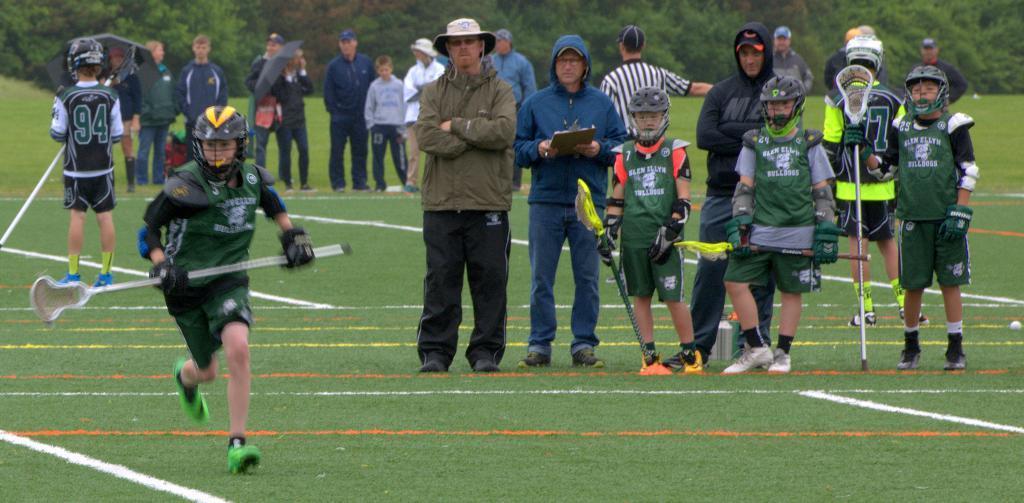Describe this image in one or two sentences. In the picture there are many people and children present, some children are wearing helmets and catching sticks with the hands, behind there are trees. 